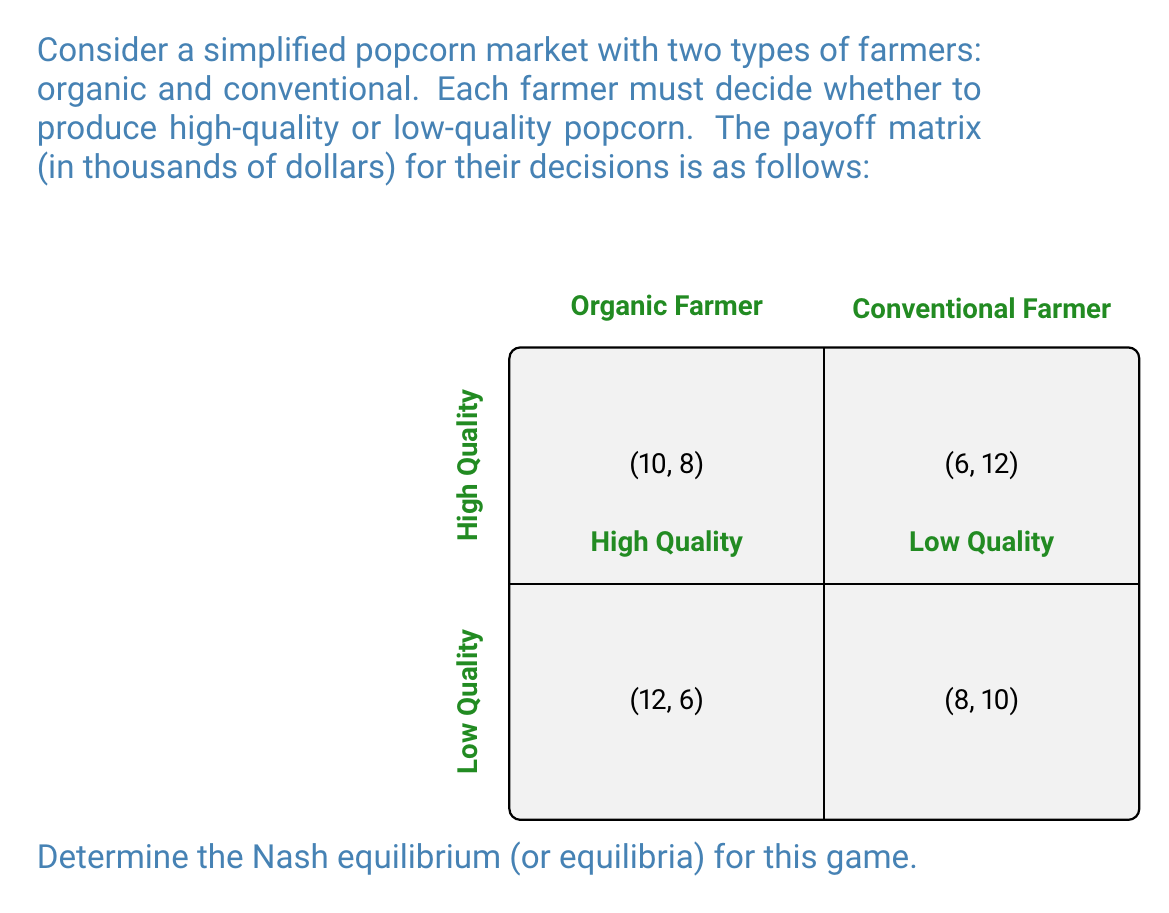Solve this math problem. To find the Nash equilibrium, we need to analyze each player's best response to the other player's strategy:

1) For the Organic Farmer:
   - If Conventional chooses High Quality: 10 > 6, so Organic chooses High Quality
   - If Conventional chooses Low Quality: 12 > 8, so Organic chooses High Quality

2) For the Conventional Farmer:
   - If Organic chooses High Quality: 8 < 12, so Conventional chooses Low Quality
   - If Organic chooses Low Quality: 6 < 10, so Conventional chooses Low Quality

We can see that regardless of what the Conventional Farmer does, the Organic Farmer's best strategy is always to produce High Quality popcorn. Similarly, regardless of what the Organic Farmer does, the Conventional Farmer's best strategy is always to produce Low Quality popcorn.

When both farmers play their best strategies, we arrive at the Nash equilibrium:
Organic Farmer produces High Quality, Conventional Farmer produces Low Quality.

At this equilibrium point (6, 12):
- Organic Farmer earns $6,000
- Conventional Farmer earns $12,000

Neither farmer can unilaterally change their strategy to improve their payoff, which is the definition of a Nash equilibrium.

To verify:
- If Organic switched to Low Quality, they would earn $8,000 instead of $6,000 (worse)
- If Conventional switched to High Quality, they would earn $8,000 instead of $12,000 (worse)

Therefore, (High Quality, Low Quality) is the unique Nash equilibrium for this game.
Answer: (High Quality, Low Quality) 